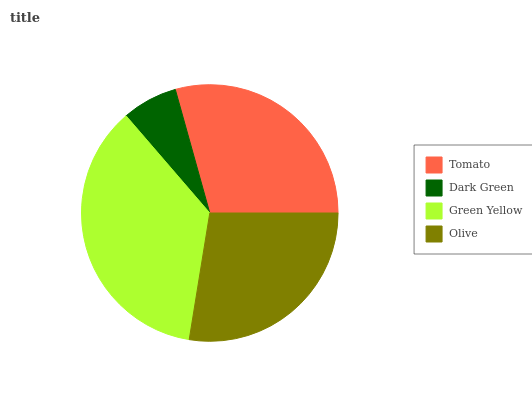Is Dark Green the minimum?
Answer yes or no. Yes. Is Green Yellow the maximum?
Answer yes or no. Yes. Is Green Yellow the minimum?
Answer yes or no. No. Is Dark Green the maximum?
Answer yes or no. No. Is Green Yellow greater than Dark Green?
Answer yes or no. Yes. Is Dark Green less than Green Yellow?
Answer yes or no. Yes. Is Dark Green greater than Green Yellow?
Answer yes or no. No. Is Green Yellow less than Dark Green?
Answer yes or no. No. Is Tomato the high median?
Answer yes or no. Yes. Is Olive the low median?
Answer yes or no. Yes. Is Green Yellow the high median?
Answer yes or no. No. Is Green Yellow the low median?
Answer yes or no. No. 